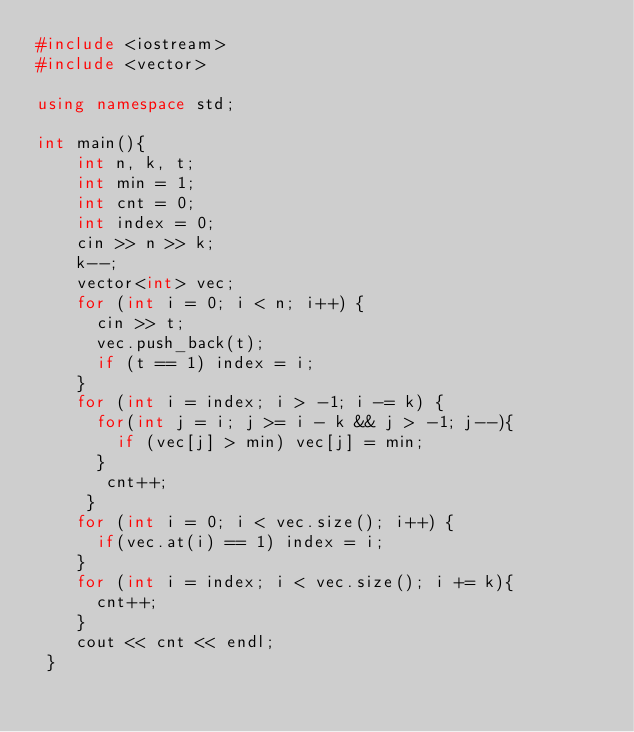<code> <loc_0><loc_0><loc_500><loc_500><_C++_>#include <iostream>
#include <vector>
 
using namespace std;
 
int main(){
    int n, k, t;
    int min = 1;
    int cnt = 0;
    int index = 0;
    cin >> n >> k;
    k--;
    vector<int> vec;
    for (int i = 0; i < n; i++) {
      cin >> t;
      vec.push_back(t);
      if (t == 1) index = i;
    }
    for (int i = index; i > -1; i -= k) {
      for(int j = i; j >= i - k && j > -1; j--){
        if (vec[j] > min) vec[j] = min;
      }
       cnt++;
     }
    for (int i = 0; i < vec.size(); i++) {
      if(vec.at(i) == 1) index = i;
    }
    for (int i = index; i < vec.size(); i += k){
      cnt++;
    }
    cout << cnt << endl;
 }</code> 